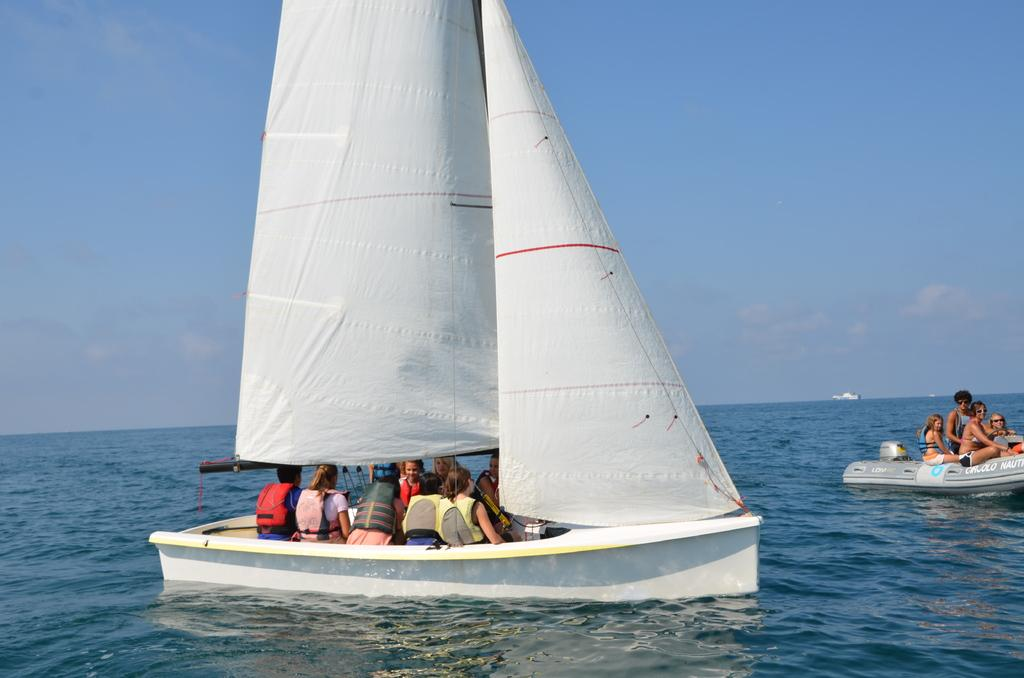What is the main subject of the image? The main subject of the image is a dinghy sailing in the center of the image. Where is the dinghy located? The dinghy is on the water. Are there any other boats visible in the image? Yes, there is another boat on the right side of the image. What type of stone can be seen falling from the sky in the image? There is no stone falling from the sky in the image. What sound can be heard in the image due to the thunder? There is no thunder present in the image, so no sound can be heard. 